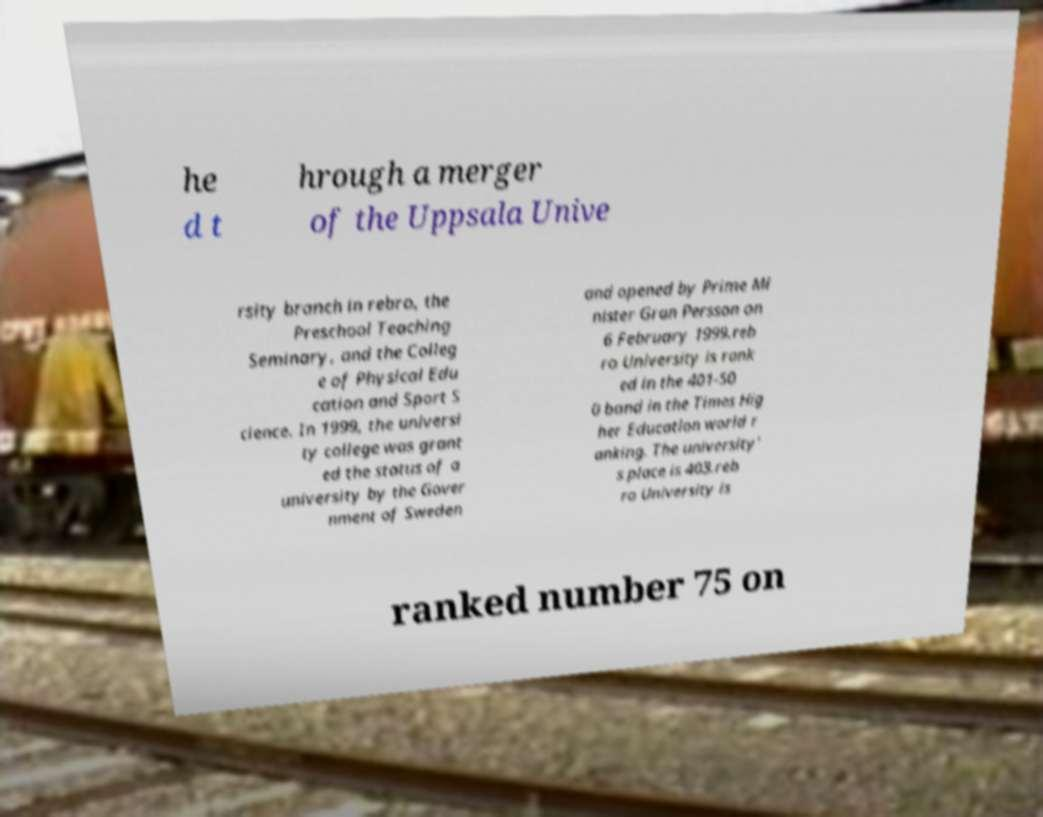Can you read and provide the text displayed in the image?This photo seems to have some interesting text. Can you extract and type it out for me? he d t hrough a merger of the Uppsala Unive rsity branch in rebro, the Preschool Teaching Seminary, and the Colleg e of Physical Edu cation and Sport S cience. In 1999, the universi ty college was grant ed the status of a university by the Gover nment of Sweden and opened by Prime Mi nister Gran Persson on 6 February 1999.reb ro University is rank ed in the 401-50 0 band in the Times Hig her Education world r anking. The university’ s place is 403.reb ro University is ranked number 75 on 